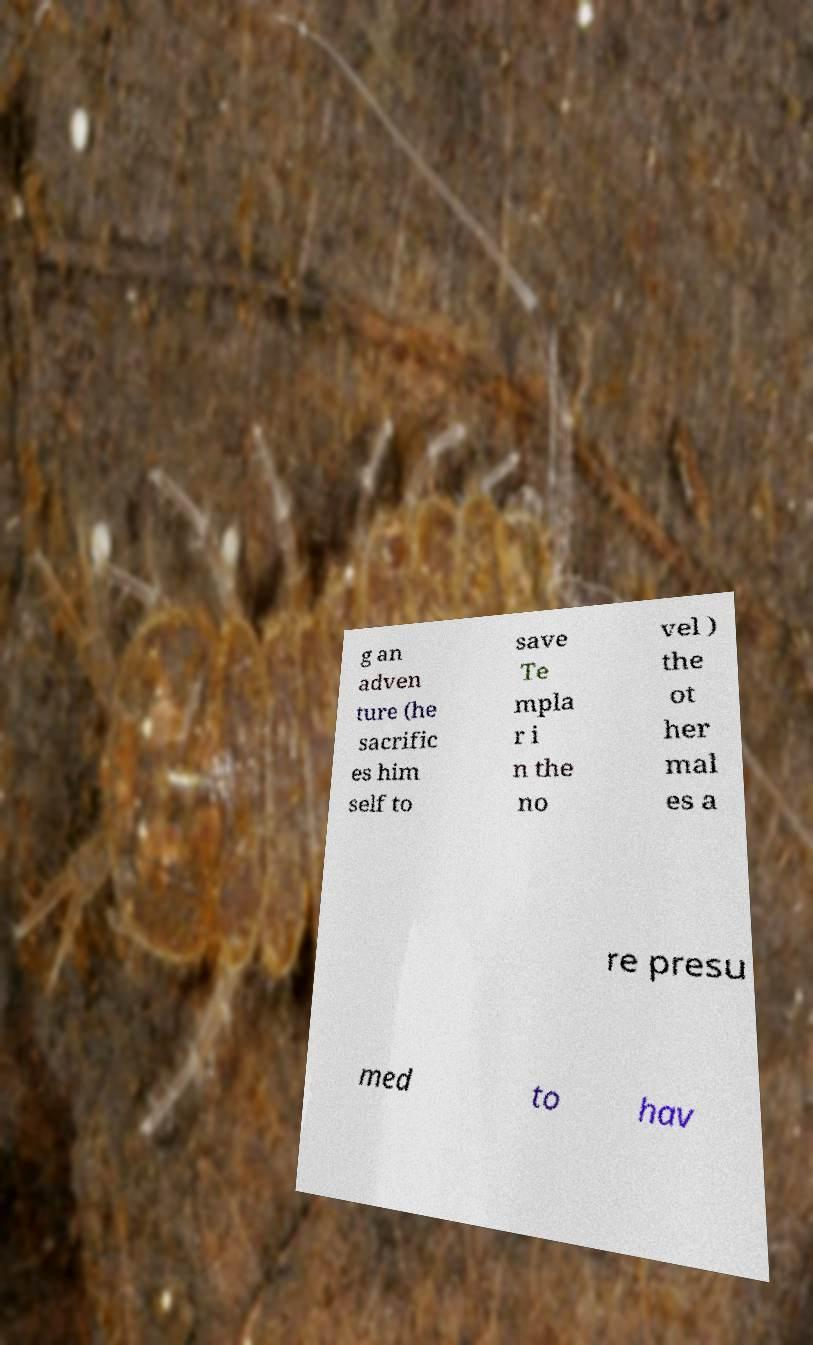What messages or text are displayed in this image? I need them in a readable, typed format. g an adven ture (he sacrific es him self to save Te mpla r i n the no vel ) the ot her mal es a re presu med to hav 